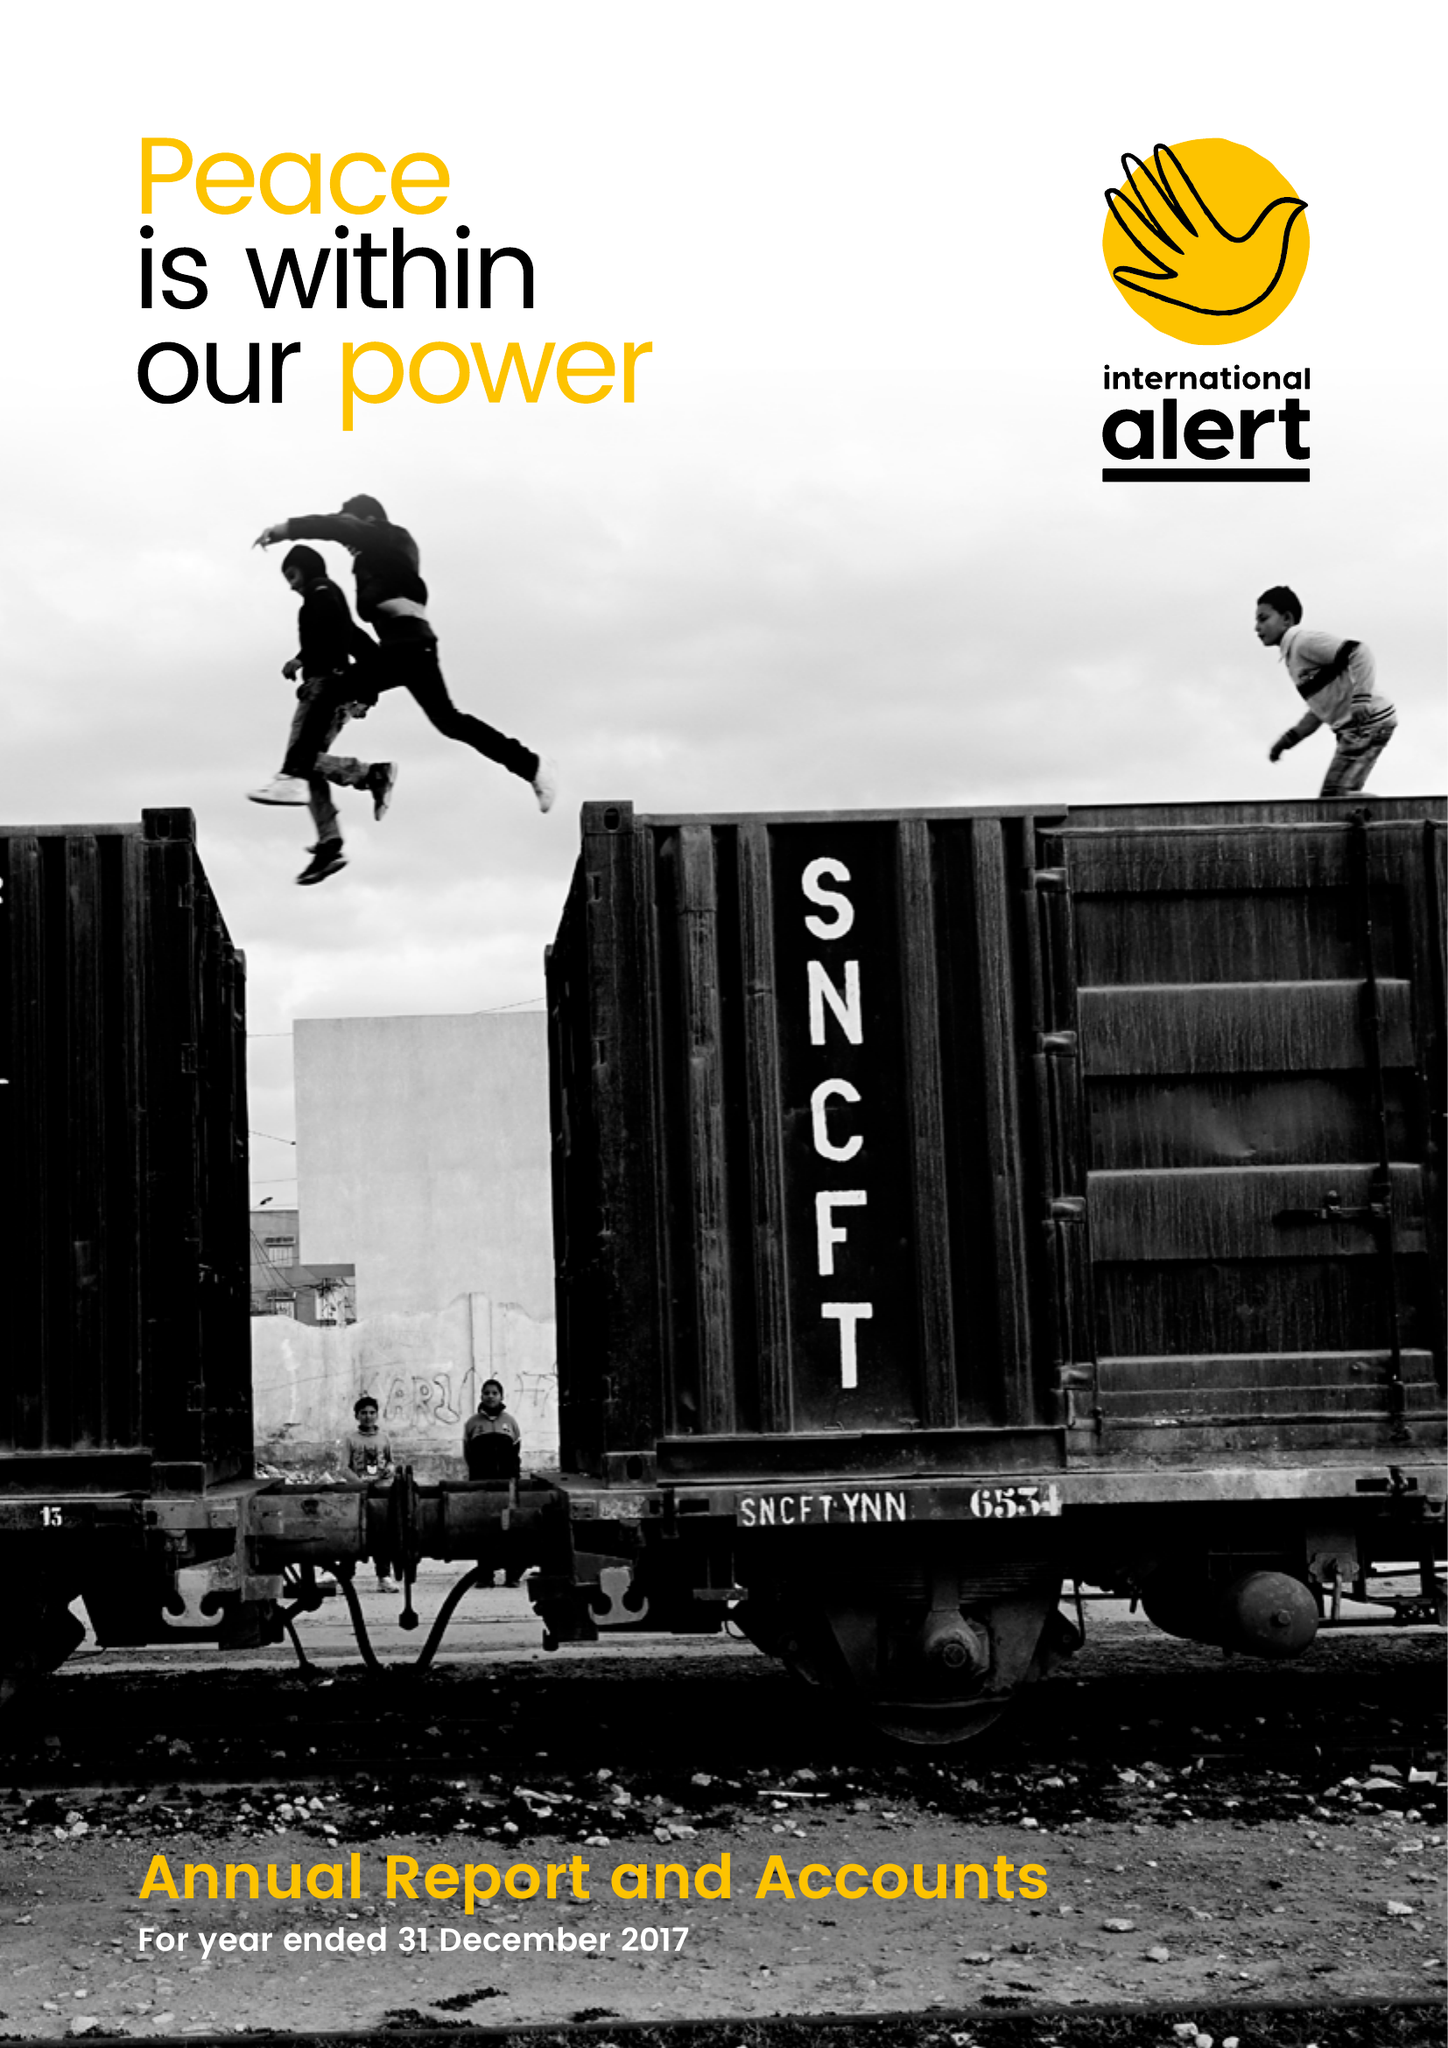What is the value for the address__street_line?
Answer the question using a single word or phrase. 346 CLAPHAM ROAD 